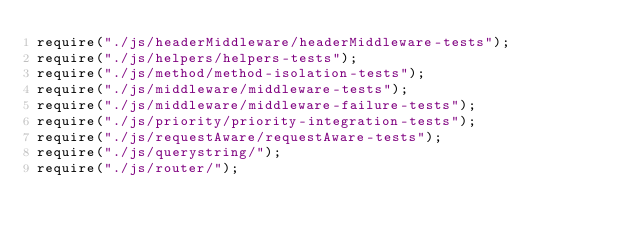Convert code to text. <code><loc_0><loc_0><loc_500><loc_500><_JavaScript_>require("./js/headerMiddleware/headerMiddleware-tests");
require("./js/helpers/helpers-tests");
require("./js/method/method-isolation-tests");
require("./js/middleware/middleware-tests");
require("./js/middleware/middleware-failure-tests");
require("./js/priority/priority-integration-tests");
require("./js/requestAware/requestAware-tests");
require("./js/querystring/");
require("./js/router/");
</code> 